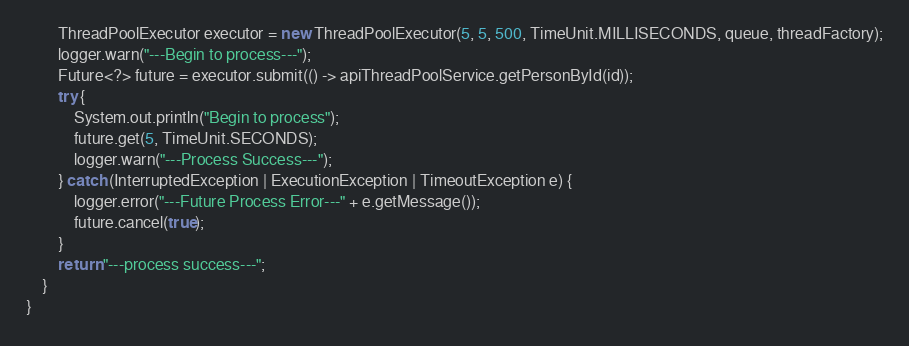Convert code to text. <code><loc_0><loc_0><loc_500><loc_500><_Java_>        ThreadPoolExecutor executor = new ThreadPoolExecutor(5, 5, 500, TimeUnit.MILLISECONDS, queue, threadFactory);
        logger.warn("---Begin to process---");
        Future<?> future = executor.submit(() -> apiThreadPoolService.getPersonById(id));
        try {
            System.out.println("Begin to process");
            future.get(5, TimeUnit.SECONDS);
            logger.warn("---Process Success---");
        } catch (InterruptedException | ExecutionException | TimeoutException e) {
            logger.error("---Future Process Error---" + e.getMessage());
            future.cancel(true);
        }
        return "---process success---";
    }
}
</code> 